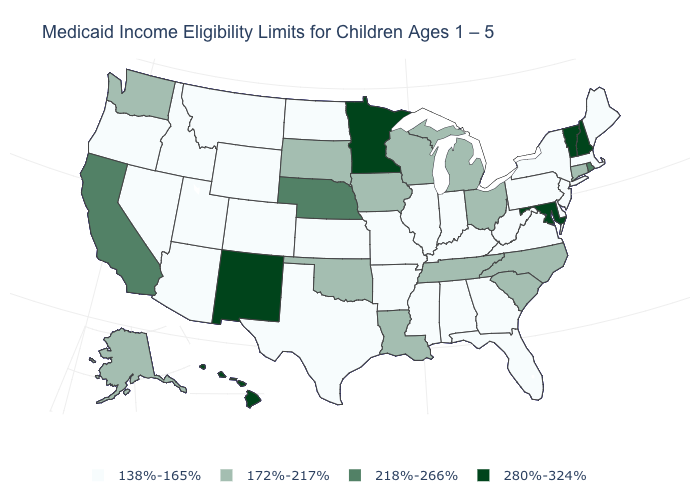Is the legend a continuous bar?
Be succinct. No. How many symbols are there in the legend?
Concise answer only. 4. Is the legend a continuous bar?
Short answer required. No. What is the lowest value in states that border Connecticut?
Keep it brief. 138%-165%. Among the states that border South Carolina , does North Carolina have the highest value?
Write a very short answer. Yes. Name the states that have a value in the range 280%-324%?
Keep it brief. Hawaii, Maryland, Minnesota, New Hampshire, New Mexico, Vermont. Is the legend a continuous bar?
Keep it brief. No. Name the states that have a value in the range 172%-217%?
Keep it brief. Alaska, Connecticut, Iowa, Louisiana, Michigan, North Carolina, Ohio, Oklahoma, South Carolina, South Dakota, Tennessee, Washington, Wisconsin. What is the highest value in the West ?
Keep it brief. 280%-324%. What is the value of Nevada?
Quick response, please. 138%-165%. Name the states that have a value in the range 138%-165%?
Quick response, please. Alabama, Arizona, Arkansas, Colorado, Delaware, Florida, Georgia, Idaho, Illinois, Indiana, Kansas, Kentucky, Maine, Massachusetts, Mississippi, Missouri, Montana, Nevada, New Jersey, New York, North Dakota, Oregon, Pennsylvania, Texas, Utah, Virginia, West Virginia, Wyoming. Among the states that border South Carolina , which have the highest value?
Keep it brief. North Carolina. Among the states that border Rhode Island , does Connecticut have the highest value?
Write a very short answer. Yes. Name the states that have a value in the range 280%-324%?
Keep it brief. Hawaii, Maryland, Minnesota, New Hampshire, New Mexico, Vermont. Name the states that have a value in the range 280%-324%?
Keep it brief. Hawaii, Maryland, Minnesota, New Hampshire, New Mexico, Vermont. 